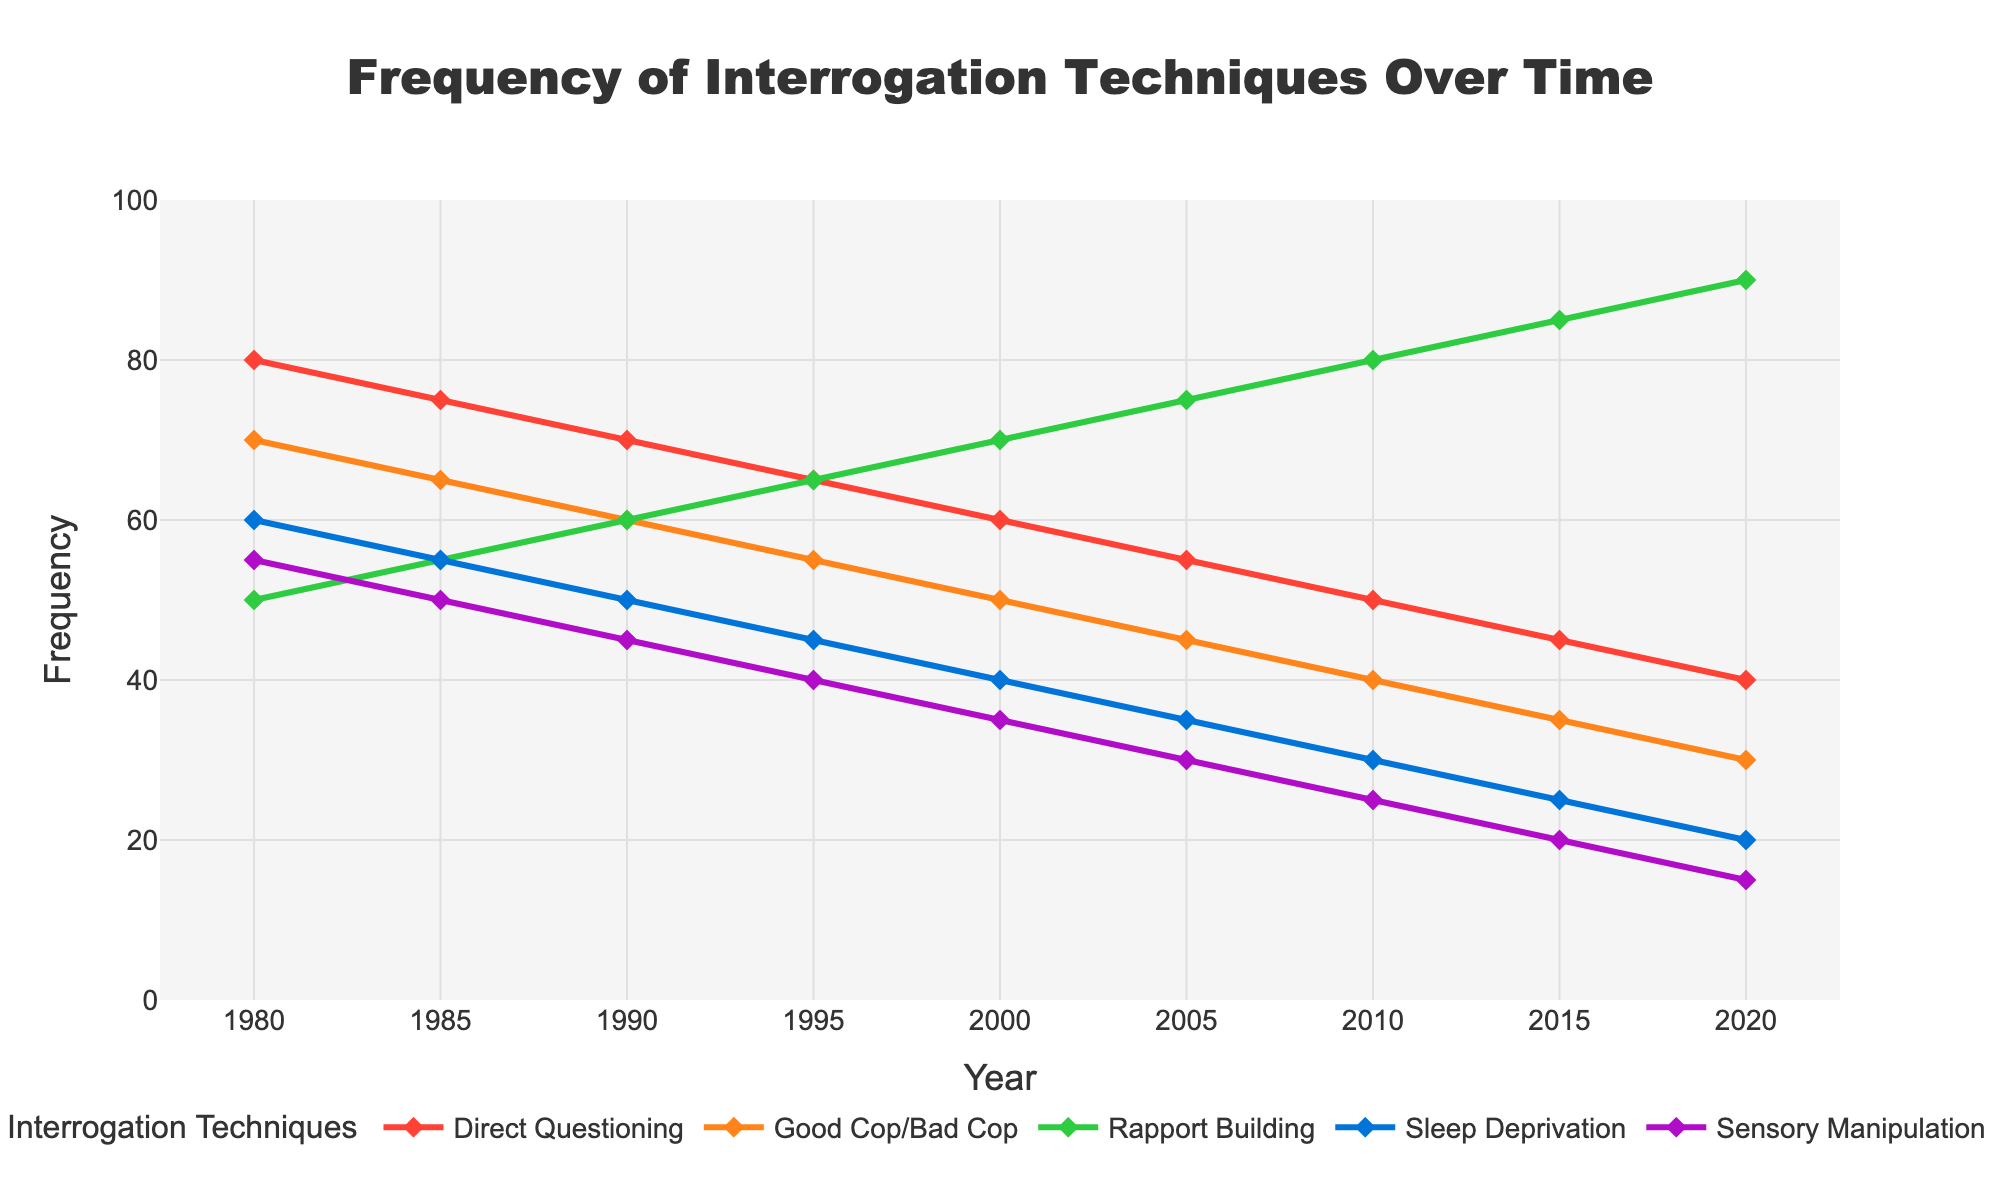What was the most frequently used interrogation technique in 1980? Look at the height of the lines at the 1980 mark. The green line for Direct Questioning is the tallest.
Answer: Direct Questioning Which interrogation technique showed a consistent increase in usage from 1980 to 2020? Observe the overall trends of the lines. Rapport Building, shown in blue, increases consistently throughout the years.
Answer: Rapport Building By how much did the usage of Sleep Deprivation change between 1980 to 2020? Look at the height of the Sleep Deprivation line in 1980 and 2020. Subtract the value in 2020 from the value in 1980 (60 - 20).
Answer: 40 In which year did Sensory Manipulation and Good Cop/Bad Cop have equal frequencies? Identify points where the lines of these two techniques intersect. This happens at the 1990 mark.
Answer: 1990 What is the average frequency of Direct Questioning over all years? Sum the frequencies of Direct Questioning for all years and divide by the number of years (80+75+70+65+60+55+50+45+40)/9.
Answer: 60 Which technique had the highest frequency in 2010 and what was its value? At the year 2010 mark, observe the highest line, which is for Rapport Building, and note its value (80).
Answer: Rapport Building, 80 By how much did the usage of Good Cop/Bad Cop decrease from 1980 to 2020? Subtract the value at 2020 from the value at 1980 (70 - 30).
Answer: 40 Between 2000 and 2010, which interrogation technique saw the most significant increase in usage? Compare the change in heights of all lines between 2000 and 2010. Rapport Building saw the largest increase from 70 to 80.
Answer: Rapport Building How many techniques had a frequency of 55 in any given year according to the chart? Observe the y-axis at the 55 mark and count the lines that pass through it. Only Direct Questioning in 1985 and Sleep Deprivation in 1980.
Answer: 2 Compare the trend of Direct Questioning and Sleep Deprivation from 1980 to 2020. Which one decreased more significantly and by how much? Look at the overall decline for both techniques from 1980 to 2020. Direct Questioning decreased from 80 to 40 (a 40-point drop), and Sleep Deprivation decreased from 60 to 20 (also a 40-point drop). Thus, they both decreased equally by 40 points.
Answer: Both decreased by 40 points 